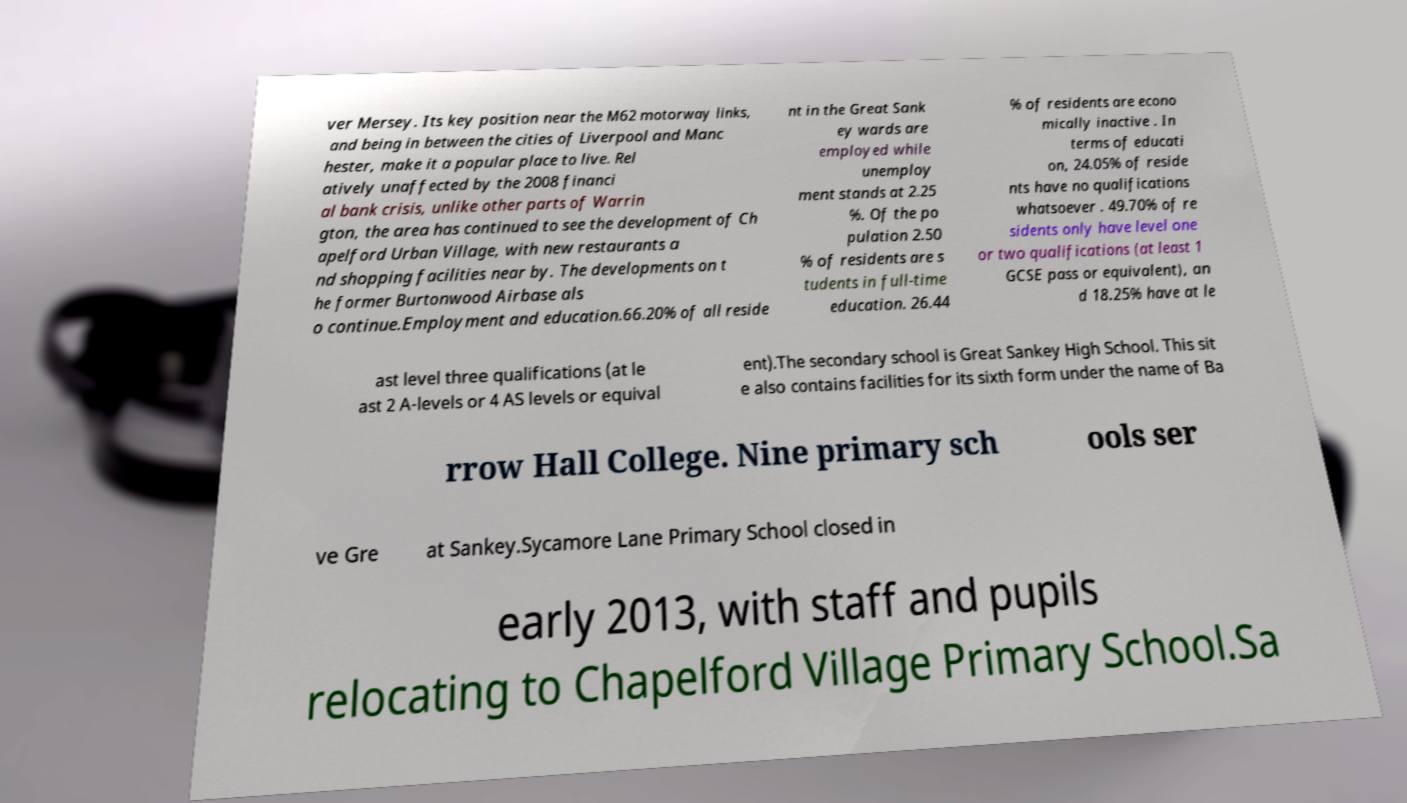For documentation purposes, I need the text within this image transcribed. Could you provide that? ver Mersey. Its key position near the M62 motorway links, and being in between the cities of Liverpool and Manc hester, make it a popular place to live. Rel atively unaffected by the 2008 financi al bank crisis, unlike other parts of Warrin gton, the area has continued to see the development of Ch apelford Urban Village, with new restaurants a nd shopping facilities near by. The developments on t he former Burtonwood Airbase als o continue.Employment and education.66.20% of all reside nt in the Great Sank ey wards are employed while unemploy ment stands at 2.25 %. Of the po pulation 2.50 % of residents are s tudents in full-time education. 26.44 % of residents are econo mically inactive . In terms of educati on, 24.05% of reside nts have no qualifications whatsoever . 49.70% of re sidents only have level one or two qualifications (at least 1 GCSE pass or equivalent), an d 18.25% have at le ast level three qualifications (at le ast 2 A-levels or 4 AS levels or equival ent).The secondary school is Great Sankey High School. This sit e also contains facilities for its sixth form under the name of Ba rrow Hall College. Nine primary sch ools ser ve Gre at Sankey.Sycamore Lane Primary School closed in early 2013, with staff and pupils relocating to Chapelford Village Primary School.Sa 